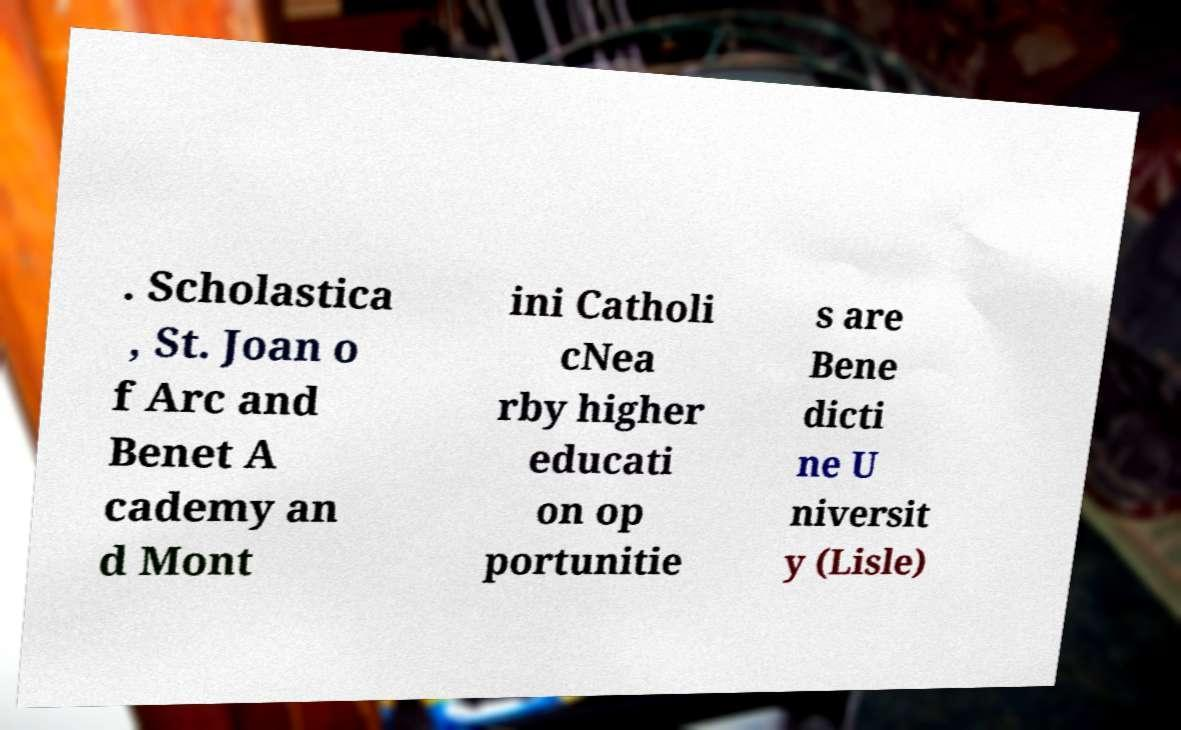Could you assist in decoding the text presented in this image and type it out clearly? . Scholastica , St. Joan o f Arc and Benet A cademy an d Mont ini Catholi cNea rby higher educati on op portunitie s are Bene dicti ne U niversit y (Lisle) 